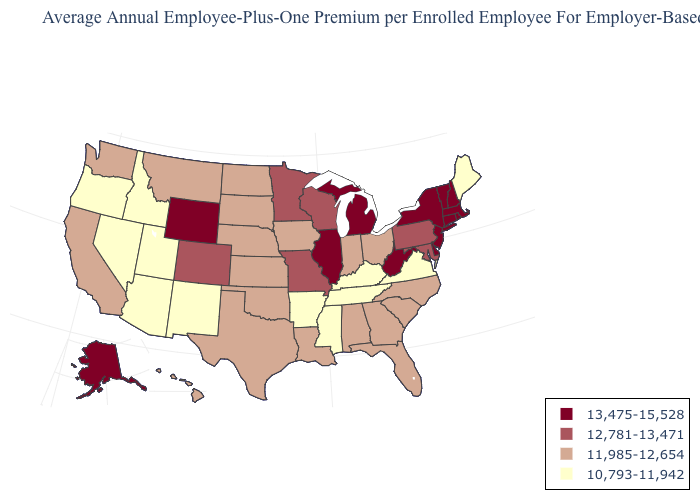Among the states that border Wisconsin , does Iowa have the lowest value?
Answer briefly. Yes. What is the value of Mississippi?
Give a very brief answer. 10,793-11,942. Does Arkansas have the same value as Illinois?
Write a very short answer. No. How many symbols are there in the legend?
Concise answer only. 4. Name the states that have a value in the range 11,985-12,654?
Give a very brief answer. Alabama, California, Florida, Georgia, Hawaii, Indiana, Iowa, Kansas, Louisiana, Montana, Nebraska, North Carolina, North Dakota, Ohio, Oklahoma, South Carolina, South Dakota, Texas, Washington. Does Illinois have the highest value in the MidWest?
Write a very short answer. Yes. What is the value of Montana?
Give a very brief answer. 11,985-12,654. Name the states that have a value in the range 13,475-15,528?
Be succinct. Alaska, Connecticut, Delaware, Illinois, Massachusetts, Michigan, New Hampshire, New Jersey, New York, Rhode Island, Vermont, West Virginia, Wyoming. Does Connecticut have the highest value in the USA?
Quick response, please. Yes. Name the states that have a value in the range 10,793-11,942?
Be succinct. Arizona, Arkansas, Idaho, Kentucky, Maine, Mississippi, Nevada, New Mexico, Oregon, Tennessee, Utah, Virginia. What is the value of Oklahoma?
Answer briefly. 11,985-12,654. What is the value of New Hampshire?
Keep it brief. 13,475-15,528. Among the states that border Oklahoma , which have the lowest value?
Concise answer only. Arkansas, New Mexico. Does Arizona have the lowest value in the USA?
Concise answer only. Yes. 